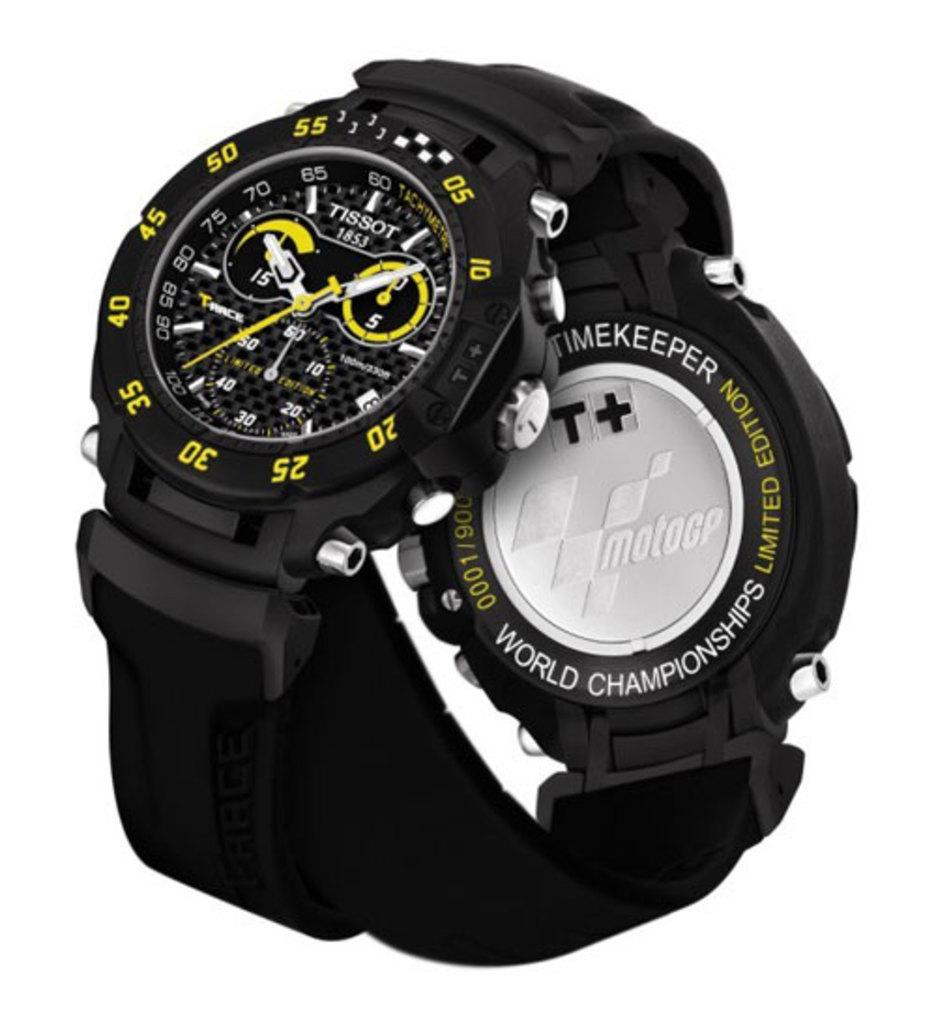What edition is the watch?
Your answer should be very brief. Limited. 